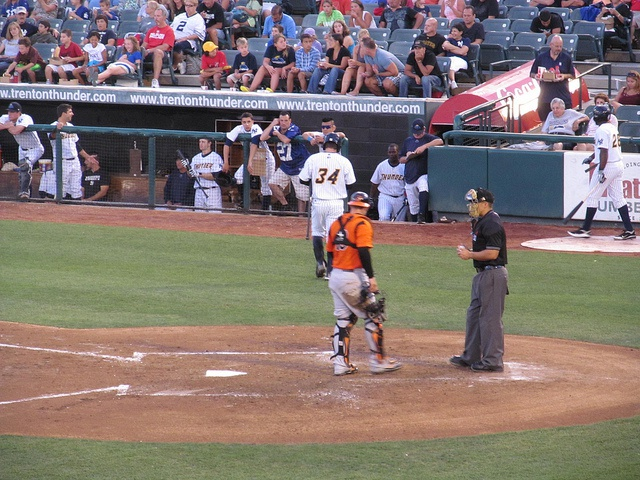Describe the objects in this image and their specific colors. I can see people in gray, black, brown, and darkgray tones, people in gray, darkgray, and black tones, people in gray and black tones, people in gray, lavender, and black tones, and people in gray, lavender, black, and darkgray tones in this image. 